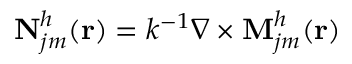<formula> <loc_0><loc_0><loc_500><loc_500>N _ { j m } ^ { h } ( r ) = k ^ { - 1 } \nabla \times M _ { j m } ^ { h } ( r )</formula> 